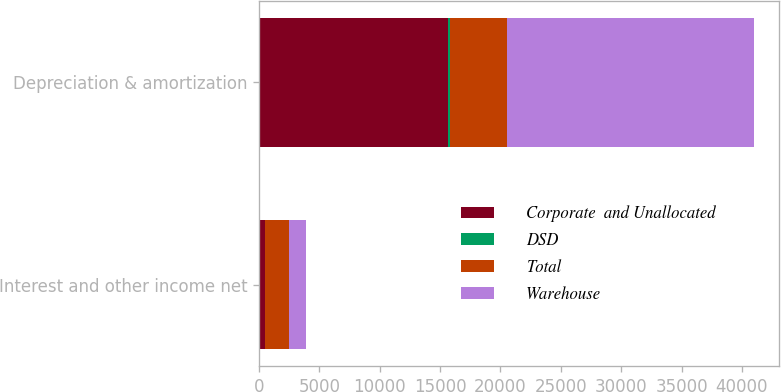<chart> <loc_0><loc_0><loc_500><loc_500><stacked_bar_chart><ecel><fcel>Interest and other income net<fcel>Depreciation & amortization<nl><fcel>Corporate  and Unallocated<fcel>494<fcel>15660<nl><fcel>DSD<fcel>2<fcel>139<nl><fcel>Total<fcel>1961<fcel>4714<nl><fcel>Warehouse<fcel>1469<fcel>20513<nl></chart> 